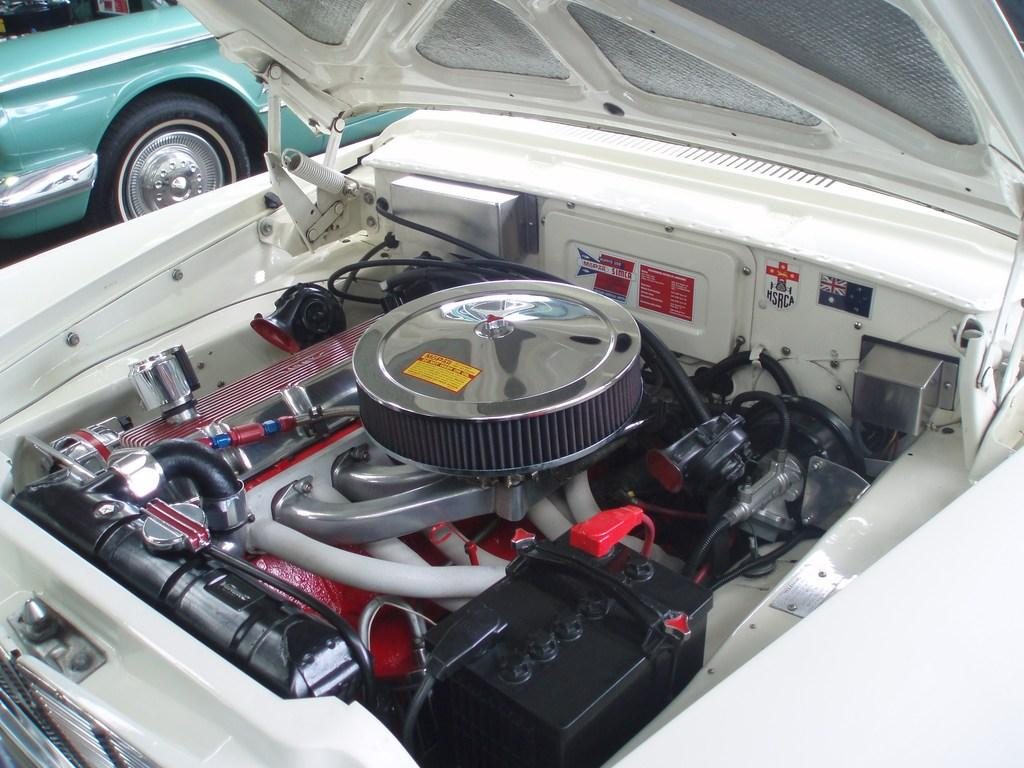What types of objects are present in the image? There are vehicles and vehicle parts in the image. Can you describe the vehicles in the image? Unfortunately, the facts provided do not give specific details about the vehicles. What kind of vehicle parts can be seen in the image? The facts provided do not specify the types of vehicle parts in the image. How much honey is in the bottle on the table in the image? There is no mention of honey or a bottle in the provided facts, so we cannot answer this question. 